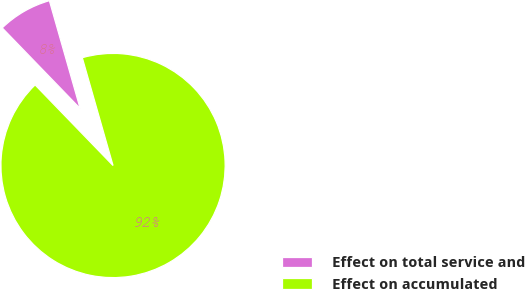Convert chart. <chart><loc_0><loc_0><loc_500><loc_500><pie_chart><fcel>Effect on total service and<fcel>Effect on accumulated<nl><fcel>7.81%<fcel>92.19%<nl></chart> 